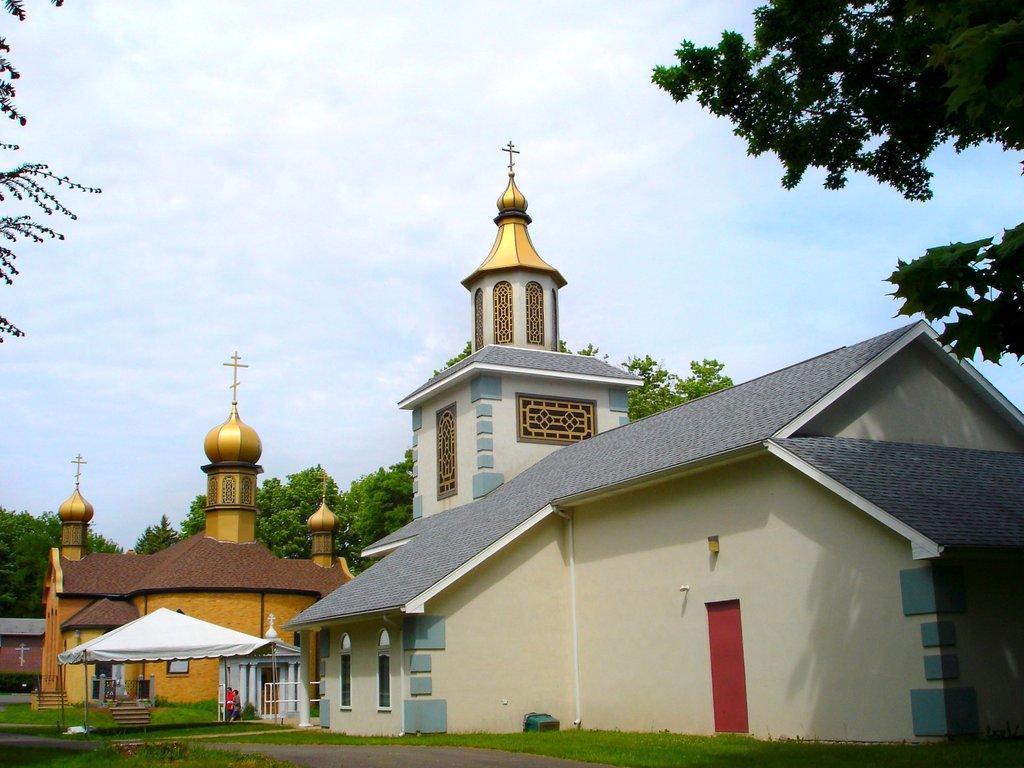Please provide a concise description of this image. At the bottom of the image there is grass. In the middle of the image there is tent. Behind the text there are some buildings. Behind the buildings there are some trees. At the top of the image there are some clouds and sky. 